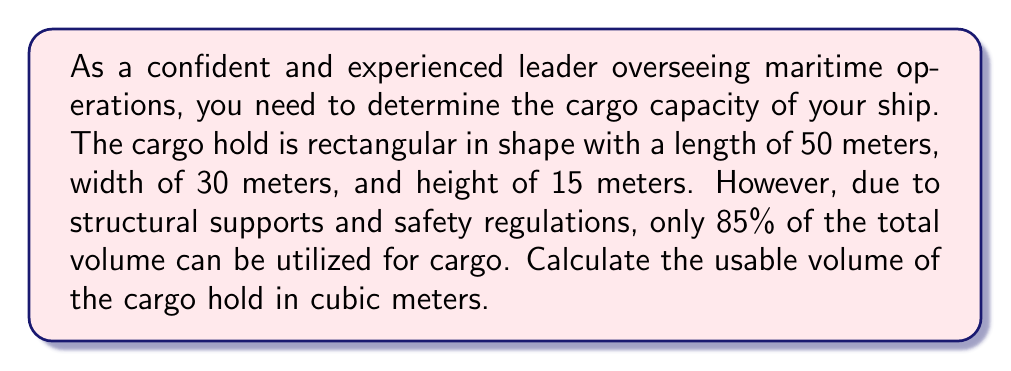Help me with this question. To solve this problem, we'll follow these steps:

1. Calculate the total volume of the rectangular cargo hold:
   The volume of a rectangular prism is given by the formula:
   $$V = l \times w \times h$$
   where $V$ is volume, $l$ is length, $w$ is width, and $h$ is height.

   Substituting the given dimensions:
   $$V = 50 \text{ m} \times 30 \text{ m} \times 15 \text{ m} = 22,500 \text{ m}^3$$

2. Calculate the usable volume:
   Since only 85% of the total volume can be used, we multiply the total volume by 0.85:
   $$V_{usable} = V_{total} \times 0.85$$
   $$V_{usable} = 22,500 \text{ m}^3 \times 0.85 = 19,125 \text{ m}^3$$

[asy]
import three;

size(200);
currentprojection=perspective(6,3,2);

draw(cuboid((0,0,0),(50,30,15)),blue);
label("50 m",(25,0,0),S);
label("30 m",(50,15,0),E);
label("15 m",(50,30,7.5),N);
label("Cargo Hold",(.5*50,.5*30,.5*15));
[/asy]
Answer: The usable volume of the cargo hold is $19,125 \text{ m}^3$. 